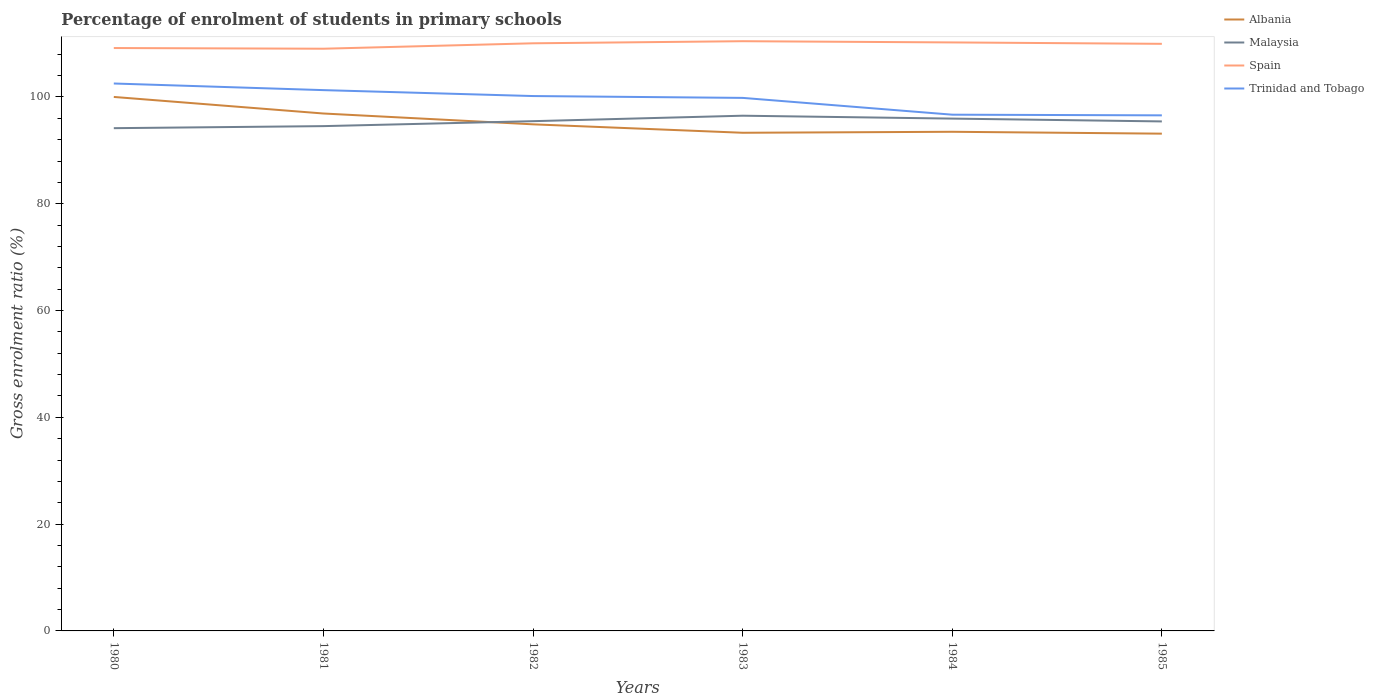How many different coloured lines are there?
Your answer should be very brief. 4. Does the line corresponding to Albania intersect with the line corresponding to Spain?
Offer a terse response. No. Across all years, what is the maximum percentage of students enrolled in primary schools in Malaysia?
Your response must be concise. 94.16. What is the total percentage of students enrolled in primary schools in Spain in the graph?
Offer a very short reply. -0.89. What is the difference between the highest and the second highest percentage of students enrolled in primary schools in Trinidad and Tobago?
Provide a short and direct response. 5.96. Is the percentage of students enrolled in primary schools in Albania strictly greater than the percentage of students enrolled in primary schools in Malaysia over the years?
Provide a short and direct response. No. How many lines are there?
Provide a succinct answer. 4. Are the values on the major ticks of Y-axis written in scientific E-notation?
Your answer should be compact. No. Does the graph contain grids?
Offer a very short reply. No. Where does the legend appear in the graph?
Ensure brevity in your answer.  Top right. What is the title of the graph?
Your response must be concise. Percentage of enrolment of students in primary schools. What is the label or title of the X-axis?
Offer a terse response. Years. What is the label or title of the Y-axis?
Keep it short and to the point. Gross enrolment ratio (%). What is the Gross enrolment ratio (%) in Albania in 1980?
Ensure brevity in your answer.  100.01. What is the Gross enrolment ratio (%) of Malaysia in 1980?
Offer a very short reply. 94.16. What is the Gross enrolment ratio (%) in Spain in 1980?
Your answer should be very brief. 109.17. What is the Gross enrolment ratio (%) in Trinidad and Tobago in 1980?
Provide a short and direct response. 102.53. What is the Gross enrolment ratio (%) of Albania in 1981?
Offer a terse response. 96.91. What is the Gross enrolment ratio (%) of Malaysia in 1981?
Offer a terse response. 94.54. What is the Gross enrolment ratio (%) in Spain in 1981?
Your response must be concise. 109.04. What is the Gross enrolment ratio (%) in Trinidad and Tobago in 1981?
Make the answer very short. 101.29. What is the Gross enrolment ratio (%) of Albania in 1982?
Give a very brief answer. 94.88. What is the Gross enrolment ratio (%) of Malaysia in 1982?
Offer a terse response. 95.47. What is the Gross enrolment ratio (%) in Spain in 1982?
Provide a succinct answer. 110.06. What is the Gross enrolment ratio (%) of Trinidad and Tobago in 1982?
Provide a succinct answer. 100.18. What is the Gross enrolment ratio (%) of Albania in 1983?
Give a very brief answer. 93.3. What is the Gross enrolment ratio (%) of Malaysia in 1983?
Give a very brief answer. 96.5. What is the Gross enrolment ratio (%) in Spain in 1983?
Make the answer very short. 110.45. What is the Gross enrolment ratio (%) of Trinidad and Tobago in 1983?
Your answer should be very brief. 99.83. What is the Gross enrolment ratio (%) of Albania in 1984?
Your response must be concise. 93.49. What is the Gross enrolment ratio (%) of Malaysia in 1984?
Make the answer very short. 95.95. What is the Gross enrolment ratio (%) in Spain in 1984?
Your answer should be compact. 110.22. What is the Gross enrolment ratio (%) of Trinidad and Tobago in 1984?
Provide a short and direct response. 96.69. What is the Gross enrolment ratio (%) of Albania in 1985?
Provide a short and direct response. 93.13. What is the Gross enrolment ratio (%) in Malaysia in 1985?
Provide a short and direct response. 95.43. What is the Gross enrolment ratio (%) in Spain in 1985?
Ensure brevity in your answer.  109.96. What is the Gross enrolment ratio (%) of Trinidad and Tobago in 1985?
Keep it short and to the point. 96.56. Across all years, what is the maximum Gross enrolment ratio (%) of Albania?
Your answer should be very brief. 100.01. Across all years, what is the maximum Gross enrolment ratio (%) of Malaysia?
Give a very brief answer. 96.5. Across all years, what is the maximum Gross enrolment ratio (%) in Spain?
Offer a very short reply. 110.45. Across all years, what is the maximum Gross enrolment ratio (%) of Trinidad and Tobago?
Your response must be concise. 102.53. Across all years, what is the minimum Gross enrolment ratio (%) in Albania?
Provide a succinct answer. 93.13. Across all years, what is the minimum Gross enrolment ratio (%) in Malaysia?
Make the answer very short. 94.16. Across all years, what is the minimum Gross enrolment ratio (%) in Spain?
Your response must be concise. 109.04. Across all years, what is the minimum Gross enrolment ratio (%) of Trinidad and Tobago?
Ensure brevity in your answer.  96.56. What is the total Gross enrolment ratio (%) in Albania in the graph?
Ensure brevity in your answer.  571.72. What is the total Gross enrolment ratio (%) of Malaysia in the graph?
Keep it short and to the point. 572.05. What is the total Gross enrolment ratio (%) of Spain in the graph?
Keep it short and to the point. 658.9. What is the total Gross enrolment ratio (%) in Trinidad and Tobago in the graph?
Provide a succinct answer. 597.08. What is the difference between the Gross enrolment ratio (%) in Albania in 1980 and that in 1981?
Ensure brevity in your answer.  3.1. What is the difference between the Gross enrolment ratio (%) in Malaysia in 1980 and that in 1981?
Give a very brief answer. -0.38. What is the difference between the Gross enrolment ratio (%) of Spain in 1980 and that in 1981?
Make the answer very short. 0.13. What is the difference between the Gross enrolment ratio (%) of Trinidad and Tobago in 1980 and that in 1981?
Provide a short and direct response. 1.24. What is the difference between the Gross enrolment ratio (%) in Albania in 1980 and that in 1982?
Provide a short and direct response. 5.13. What is the difference between the Gross enrolment ratio (%) of Malaysia in 1980 and that in 1982?
Make the answer very short. -1.31. What is the difference between the Gross enrolment ratio (%) in Spain in 1980 and that in 1982?
Keep it short and to the point. -0.89. What is the difference between the Gross enrolment ratio (%) of Trinidad and Tobago in 1980 and that in 1982?
Ensure brevity in your answer.  2.35. What is the difference between the Gross enrolment ratio (%) in Albania in 1980 and that in 1983?
Offer a terse response. 6.71. What is the difference between the Gross enrolment ratio (%) in Malaysia in 1980 and that in 1983?
Ensure brevity in your answer.  -2.34. What is the difference between the Gross enrolment ratio (%) in Spain in 1980 and that in 1983?
Ensure brevity in your answer.  -1.28. What is the difference between the Gross enrolment ratio (%) in Trinidad and Tobago in 1980 and that in 1983?
Offer a very short reply. 2.69. What is the difference between the Gross enrolment ratio (%) in Albania in 1980 and that in 1984?
Give a very brief answer. 6.52. What is the difference between the Gross enrolment ratio (%) in Malaysia in 1980 and that in 1984?
Give a very brief answer. -1.79. What is the difference between the Gross enrolment ratio (%) in Spain in 1980 and that in 1984?
Offer a terse response. -1.05. What is the difference between the Gross enrolment ratio (%) of Trinidad and Tobago in 1980 and that in 1984?
Ensure brevity in your answer.  5.84. What is the difference between the Gross enrolment ratio (%) of Albania in 1980 and that in 1985?
Your answer should be very brief. 6.88. What is the difference between the Gross enrolment ratio (%) in Malaysia in 1980 and that in 1985?
Your answer should be compact. -1.27. What is the difference between the Gross enrolment ratio (%) in Spain in 1980 and that in 1985?
Offer a very short reply. -0.79. What is the difference between the Gross enrolment ratio (%) of Trinidad and Tobago in 1980 and that in 1985?
Keep it short and to the point. 5.96. What is the difference between the Gross enrolment ratio (%) in Albania in 1981 and that in 1982?
Offer a very short reply. 2.03. What is the difference between the Gross enrolment ratio (%) of Malaysia in 1981 and that in 1982?
Your response must be concise. -0.93. What is the difference between the Gross enrolment ratio (%) in Spain in 1981 and that in 1982?
Give a very brief answer. -1.02. What is the difference between the Gross enrolment ratio (%) of Trinidad and Tobago in 1981 and that in 1982?
Ensure brevity in your answer.  1.11. What is the difference between the Gross enrolment ratio (%) in Albania in 1981 and that in 1983?
Your response must be concise. 3.61. What is the difference between the Gross enrolment ratio (%) in Malaysia in 1981 and that in 1983?
Ensure brevity in your answer.  -1.95. What is the difference between the Gross enrolment ratio (%) in Spain in 1981 and that in 1983?
Your response must be concise. -1.41. What is the difference between the Gross enrolment ratio (%) of Trinidad and Tobago in 1981 and that in 1983?
Provide a succinct answer. 1.45. What is the difference between the Gross enrolment ratio (%) of Albania in 1981 and that in 1984?
Provide a succinct answer. 3.42. What is the difference between the Gross enrolment ratio (%) in Malaysia in 1981 and that in 1984?
Give a very brief answer. -1.41. What is the difference between the Gross enrolment ratio (%) of Spain in 1981 and that in 1984?
Ensure brevity in your answer.  -1.18. What is the difference between the Gross enrolment ratio (%) in Trinidad and Tobago in 1981 and that in 1984?
Your response must be concise. 4.6. What is the difference between the Gross enrolment ratio (%) in Albania in 1981 and that in 1985?
Ensure brevity in your answer.  3.77. What is the difference between the Gross enrolment ratio (%) in Malaysia in 1981 and that in 1985?
Your answer should be very brief. -0.88. What is the difference between the Gross enrolment ratio (%) in Spain in 1981 and that in 1985?
Keep it short and to the point. -0.92. What is the difference between the Gross enrolment ratio (%) in Trinidad and Tobago in 1981 and that in 1985?
Keep it short and to the point. 4.72. What is the difference between the Gross enrolment ratio (%) of Albania in 1982 and that in 1983?
Offer a terse response. 1.58. What is the difference between the Gross enrolment ratio (%) of Malaysia in 1982 and that in 1983?
Your answer should be compact. -1.02. What is the difference between the Gross enrolment ratio (%) in Spain in 1982 and that in 1983?
Your answer should be compact. -0.39. What is the difference between the Gross enrolment ratio (%) of Trinidad and Tobago in 1982 and that in 1983?
Provide a short and direct response. 0.34. What is the difference between the Gross enrolment ratio (%) in Albania in 1982 and that in 1984?
Provide a short and direct response. 1.39. What is the difference between the Gross enrolment ratio (%) of Malaysia in 1982 and that in 1984?
Offer a terse response. -0.48. What is the difference between the Gross enrolment ratio (%) of Spain in 1982 and that in 1984?
Your answer should be very brief. -0.17. What is the difference between the Gross enrolment ratio (%) in Trinidad and Tobago in 1982 and that in 1984?
Offer a very short reply. 3.49. What is the difference between the Gross enrolment ratio (%) of Albania in 1982 and that in 1985?
Ensure brevity in your answer.  1.75. What is the difference between the Gross enrolment ratio (%) of Malaysia in 1982 and that in 1985?
Your answer should be compact. 0.05. What is the difference between the Gross enrolment ratio (%) in Spain in 1982 and that in 1985?
Your answer should be compact. 0.1. What is the difference between the Gross enrolment ratio (%) in Trinidad and Tobago in 1982 and that in 1985?
Provide a short and direct response. 3.61. What is the difference between the Gross enrolment ratio (%) in Albania in 1983 and that in 1984?
Offer a terse response. -0.18. What is the difference between the Gross enrolment ratio (%) of Malaysia in 1983 and that in 1984?
Your answer should be compact. 0.54. What is the difference between the Gross enrolment ratio (%) of Spain in 1983 and that in 1984?
Provide a short and direct response. 0.23. What is the difference between the Gross enrolment ratio (%) of Trinidad and Tobago in 1983 and that in 1984?
Keep it short and to the point. 3.15. What is the difference between the Gross enrolment ratio (%) in Albania in 1983 and that in 1985?
Your answer should be very brief. 0.17. What is the difference between the Gross enrolment ratio (%) in Malaysia in 1983 and that in 1985?
Your response must be concise. 1.07. What is the difference between the Gross enrolment ratio (%) in Spain in 1983 and that in 1985?
Offer a very short reply. 0.49. What is the difference between the Gross enrolment ratio (%) of Trinidad and Tobago in 1983 and that in 1985?
Offer a very short reply. 3.27. What is the difference between the Gross enrolment ratio (%) in Albania in 1984 and that in 1985?
Offer a terse response. 0.35. What is the difference between the Gross enrolment ratio (%) of Malaysia in 1984 and that in 1985?
Give a very brief answer. 0.53. What is the difference between the Gross enrolment ratio (%) in Spain in 1984 and that in 1985?
Give a very brief answer. 0.26. What is the difference between the Gross enrolment ratio (%) of Trinidad and Tobago in 1984 and that in 1985?
Your response must be concise. 0.12. What is the difference between the Gross enrolment ratio (%) in Albania in 1980 and the Gross enrolment ratio (%) in Malaysia in 1981?
Keep it short and to the point. 5.47. What is the difference between the Gross enrolment ratio (%) in Albania in 1980 and the Gross enrolment ratio (%) in Spain in 1981?
Give a very brief answer. -9.03. What is the difference between the Gross enrolment ratio (%) of Albania in 1980 and the Gross enrolment ratio (%) of Trinidad and Tobago in 1981?
Your answer should be very brief. -1.28. What is the difference between the Gross enrolment ratio (%) in Malaysia in 1980 and the Gross enrolment ratio (%) in Spain in 1981?
Make the answer very short. -14.88. What is the difference between the Gross enrolment ratio (%) in Malaysia in 1980 and the Gross enrolment ratio (%) in Trinidad and Tobago in 1981?
Give a very brief answer. -7.13. What is the difference between the Gross enrolment ratio (%) of Spain in 1980 and the Gross enrolment ratio (%) of Trinidad and Tobago in 1981?
Give a very brief answer. 7.88. What is the difference between the Gross enrolment ratio (%) of Albania in 1980 and the Gross enrolment ratio (%) of Malaysia in 1982?
Your response must be concise. 4.54. What is the difference between the Gross enrolment ratio (%) in Albania in 1980 and the Gross enrolment ratio (%) in Spain in 1982?
Keep it short and to the point. -10.05. What is the difference between the Gross enrolment ratio (%) in Albania in 1980 and the Gross enrolment ratio (%) in Trinidad and Tobago in 1982?
Ensure brevity in your answer.  -0.17. What is the difference between the Gross enrolment ratio (%) in Malaysia in 1980 and the Gross enrolment ratio (%) in Spain in 1982?
Your answer should be very brief. -15.9. What is the difference between the Gross enrolment ratio (%) of Malaysia in 1980 and the Gross enrolment ratio (%) of Trinidad and Tobago in 1982?
Offer a terse response. -6.02. What is the difference between the Gross enrolment ratio (%) in Spain in 1980 and the Gross enrolment ratio (%) in Trinidad and Tobago in 1982?
Your answer should be compact. 8.99. What is the difference between the Gross enrolment ratio (%) in Albania in 1980 and the Gross enrolment ratio (%) in Malaysia in 1983?
Offer a terse response. 3.51. What is the difference between the Gross enrolment ratio (%) in Albania in 1980 and the Gross enrolment ratio (%) in Spain in 1983?
Give a very brief answer. -10.44. What is the difference between the Gross enrolment ratio (%) in Albania in 1980 and the Gross enrolment ratio (%) in Trinidad and Tobago in 1983?
Your answer should be compact. 0.18. What is the difference between the Gross enrolment ratio (%) in Malaysia in 1980 and the Gross enrolment ratio (%) in Spain in 1983?
Provide a short and direct response. -16.29. What is the difference between the Gross enrolment ratio (%) in Malaysia in 1980 and the Gross enrolment ratio (%) in Trinidad and Tobago in 1983?
Provide a succinct answer. -5.67. What is the difference between the Gross enrolment ratio (%) in Spain in 1980 and the Gross enrolment ratio (%) in Trinidad and Tobago in 1983?
Make the answer very short. 9.34. What is the difference between the Gross enrolment ratio (%) of Albania in 1980 and the Gross enrolment ratio (%) of Malaysia in 1984?
Provide a short and direct response. 4.06. What is the difference between the Gross enrolment ratio (%) of Albania in 1980 and the Gross enrolment ratio (%) of Spain in 1984?
Offer a terse response. -10.21. What is the difference between the Gross enrolment ratio (%) of Albania in 1980 and the Gross enrolment ratio (%) of Trinidad and Tobago in 1984?
Make the answer very short. 3.32. What is the difference between the Gross enrolment ratio (%) in Malaysia in 1980 and the Gross enrolment ratio (%) in Spain in 1984?
Your response must be concise. -16.06. What is the difference between the Gross enrolment ratio (%) of Malaysia in 1980 and the Gross enrolment ratio (%) of Trinidad and Tobago in 1984?
Keep it short and to the point. -2.53. What is the difference between the Gross enrolment ratio (%) in Spain in 1980 and the Gross enrolment ratio (%) in Trinidad and Tobago in 1984?
Your response must be concise. 12.48. What is the difference between the Gross enrolment ratio (%) in Albania in 1980 and the Gross enrolment ratio (%) in Malaysia in 1985?
Provide a short and direct response. 4.59. What is the difference between the Gross enrolment ratio (%) of Albania in 1980 and the Gross enrolment ratio (%) of Spain in 1985?
Provide a succinct answer. -9.95. What is the difference between the Gross enrolment ratio (%) of Albania in 1980 and the Gross enrolment ratio (%) of Trinidad and Tobago in 1985?
Offer a terse response. 3.45. What is the difference between the Gross enrolment ratio (%) of Malaysia in 1980 and the Gross enrolment ratio (%) of Spain in 1985?
Your answer should be compact. -15.8. What is the difference between the Gross enrolment ratio (%) in Malaysia in 1980 and the Gross enrolment ratio (%) in Trinidad and Tobago in 1985?
Make the answer very short. -2.4. What is the difference between the Gross enrolment ratio (%) of Spain in 1980 and the Gross enrolment ratio (%) of Trinidad and Tobago in 1985?
Your response must be concise. 12.61. What is the difference between the Gross enrolment ratio (%) in Albania in 1981 and the Gross enrolment ratio (%) in Malaysia in 1982?
Provide a succinct answer. 1.44. What is the difference between the Gross enrolment ratio (%) in Albania in 1981 and the Gross enrolment ratio (%) in Spain in 1982?
Your response must be concise. -13.15. What is the difference between the Gross enrolment ratio (%) in Albania in 1981 and the Gross enrolment ratio (%) in Trinidad and Tobago in 1982?
Ensure brevity in your answer.  -3.27. What is the difference between the Gross enrolment ratio (%) in Malaysia in 1981 and the Gross enrolment ratio (%) in Spain in 1982?
Your answer should be compact. -15.51. What is the difference between the Gross enrolment ratio (%) of Malaysia in 1981 and the Gross enrolment ratio (%) of Trinidad and Tobago in 1982?
Provide a short and direct response. -5.63. What is the difference between the Gross enrolment ratio (%) of Spain in 1981 and the Gross enrolment ratio (%) of Trinidad and Tobago in 1982?
Your answer should be compact. 8.86. What is the difference between the Gross enrolment ratio (%) of Albania in 1981 and the Gross enrolment ratio (%) of Malaysia in 1983?
Your response must be concise. 0.41. What is the difference between the Gross enrolment ratio (%) of Albania in 1981 and the Gross enrolment ratio (%) of Spain in 1983?
Your answer should be compact. -13.54. What is the difference between the Gross enrolment ratio (%) of Albania in 1981 and the Gross enrolment ratio (%) of Trinidad and Tobago in 1983?
Provide a short and direct response. -2.93. What is the difference between the Gross enrolment ratio (%) of Malaysia in 1981 and the Gross enrolment ratio (%) of Spain in 1983?
Offer a terse response. -15.91. What is the difference between the Gross enrolment ratio (%) of Malaysia in 1981 and the Gross enrolment ratio (%) of Trinidad and Tobago in 1983?
Make the answer very short. -5.29. What is the difference between the Gross enrolment ratio (%) of Spain in 1981 and the Gross enrolment ratio (%) of Trinidad and Tobago in 1983?
Your answer should be compact. 9.21. What is the difference between the Gross enrolment ratio (%) of Albania in 1981 and the Gross enrolment ratio (%) of Malaysia in 1984?
Ensure brevity in your answer.  0.95. What is the difference between the Gross enrolment ratio (%) in Albania in 1981 and the Gross enrolment ratio (%) in Spain in 1984?
Offer a very short reply. -13.31. What is the difference between the Gross enrolment ratio (%) in Albania in 1981 and the Gross enrolment ratio (%) in Trinidad and Tobago in 1984?
Your answer should be compact. 0.22. What is the difference between the Gross enrolment ratio (%) of Malaysia in 1981 and the Gross enrolment ratio (%) of Spain in 1984?
Keep it short and to the point. -15.68. What is the difference between the Gross enrolment ratio (%) in Malaysia in 1981 and the Gross enrolment ratio (%) in Trinidad and Tobago in 1984?
Make the answer very short. -2.14. What is the difference between the Gross enrolment ratio (%) in Spain in 1981 and the Gross enrolment ratio (%) in Trinidad and Tobago in 1984?
Your answer should be very brief. 12.35. What is the difference between the Gross enrolment ratio (%) in Albania in 1981 and the Gross enrolment ratio (%) in Malaysia in 1985?
Ensure brevity in your answer.  1.48. What is the difference between the Gross enrolment ratio (%) in Albania in 1981 and the Gross enrolment ratio (%) in Spain in 1985?
Your answer should be compact. -13.05. What is the difference between the Gross enrolment ratio (%) of Albania in 1981 and the Gross enrolment ratio (%) of Trinidad and Tobago in 1985?
Your response must be concise. 0.34. What is the difference between the Gross enrolment ratio (%) in Malaysia in 1981 and the Gross enrolment ratio (%) in Spain in 1985?
Provide a succinct answer. -15.41. What is the difference between the Gross enrolment ratio (%) of Malaysia in 1981 and the Gross enrolment ratio (%) of Trinidad and Tobago in 1985?
Offer a terse response. -2.02. What is the difference between the Gross enrolment ratio (%) in Spain in 1981 and the Gross enrolment ratio (%) in Trinidad and Tobago in 1985?
Offer a very short reply. 12.48. What is the difference between the Gross enrolment ratio (%) of Albania in 1982 and the Gross enrolment ratio (%) of Malaysia in 1983?
Give a very brief answer. -1.61. What is the difference between the Gross enrolment ratio (%) in Albania in 1982 and the Gross enrolment ratio (%) in Spain in 1983?
Offer a very short reply. -15.57. What is the difference between the Gross enrolment ratio (%) of Albania in 1982 and the Gross enrolment ratio (%) of Trinidad and Tobago in 1983?
Your answer should be compact. -4.95. What is the difference between the Gross enrolment ratio (%) in Malaysia in 1982 and the Gross enrolment ratio (%) in Spain in 1983?
Your answer should be compact. -14.98. What is the difference between the Gross enrolment ratio (%) of Malaysia in 1982 and the Gross enrolment ratio (%) of Trinidad and Tobago in 1983?
Give a very brief answer. -4.36. What is the difference between the Gross enrolment ratio (%) of Spain in 1982 and the Gross enrolment ratio (%) of Trinidad and Tobago in 1983?
Your answer should be compact. 10.22. What is the difference between the Gross enrolment ratio (%) of Albania in 1982 and the Gross enrolment ratio (%) of Malaysia in 1984?
Keep it short and to the point. -1.07. What is the difference between the Gross enrolment ratio (%) of Albania in 1982 and the Gross enrolment ratio (%) of Spain in 1984?
Your response must be concise. -15.34. What is the difference between the Gross enrolment ratio (%) in Albania in 1982 and the Gross enrolment ratio (%) in Trinidad and Tobago in 1984?
Provide a succinct answer. -1.81. What is the difference between the Gross enrolment ratio (%) of Malaysia in 1982 and the Gross enrolment ratio (%) of Spain in 1984?
Offer a very short reply. -14.75. What is the difference between the Gross enrolment ratio (%) in Malaysia in 1982 and the Gross enrolment ratio (%) in Trinidad and Tobago in 1984?
Your answer should be very brief. -1.22. What is the difference between the Gross enrolment ratio (%) in Spain in 1982 and the Gross enrolment ratio (%) in Trinidad and Tobago in 1984?
Your answer should be very brief. 13.37. What is the difference between the Gross enrolment ratio (%) in Albania in 1982 and the Gross enrolment ratio (%) in Malaysia in 1985?
Provide a succinct answer. -0.54. What is the difference between the Gross enrolment ratio (%) in Albania in 1982 and the Gross enrolment ratio (%) in Spain in 1985?
Make the answer very short. -15.08. What is the difference between the Gross enrolment ratio (%) in Albania in 1982 and the Gross enrolment ratio (%) in Trinidad and Tobago in 1985?
Keep it short and to the point. -1.68. What is the difference between the Gross enrolment ratio (%) in Malaysia in 1982 and the Gross enrolment ratio (%) in Spain in 1985?
Offer a very short reply. -14.49. What is the difference between the Gross enrolment ratio (%) of Malaysia in 1982 and the Gross enrolment ratio (%) of Trinidad and Tobago in 1985?
Ensure brevity in your answer.  -1.09. What is the difference between the Gross enrolment ratio (%) in Spain in 1982 and the Gross enrolment ratio (%) in Trinidad and Tobago in 1985?
Provide a short and direct response. 13.49. What is the difference between the Gross enrolment ratio (%) of Albania in 1983 and the Gross enrolment ratio (%) of Malaysia in 1984?
Give a very brief answer. -2.65. What is the difference between the Gross enrolment ratio (%) in Albania in 1983 and the Gross enrolment ratio (%) in Spain in 1984?
Your response must be concise. -16.92. What is the difference between the Gross enrolment ratio (%) of Albania in 1983 and the Gross enrolment ratio (%) of Trinidad and Tobago in 1984?
Your answer should be compact. -3.39. What is the difference between the Gross enrolment ratio (%) of Malaysia in 1983 and the Gross enrolment ratio (%) of Spain in 1984?
Offer a terse response. -13.73. What is the difference between the Gross enrolment ratio (%) of Malaysia in 1983 and the Gross enrolment ratio (%) of Trinidad and Tobago in 1984?
Keep it short and to the point. -0.19. What is the difference between the Gross enrolment ratio (%) in Spain in 1983 and the Gross enrolment ratio (%) in Trinidad and Tobago in 1984?
Provide a succinct answer. 13.76. What is the difference between the Gross enrolment ratio (%) of Albania in 1983 and the Gross enrolment ratio (%) of Malaysia in 1985?
Offer a terse response. -2.12. What is the difference between the Gross enrolment ratio (%) in Albania in 1983 and the Gross enrolment ratio (%) in Spain in 1985?
Offer a very short reply. -16.66. What is the difference between the Gross enrolment ratio (%) of Albania in 1983 and the Gross enrolment ratio (%) of Trinidad and Tobago in 1985?
Offer a terse response. -3.26. What is the difference between the Gross enrolment ratio (%) in Malaysia in 1983 and the Gross enrolment ratio (%) in Spain in 1985?
Your response must be concise. -13.46. What is the difference between the Gross enrolment ratio (%) in Malaysia in 1983 and the Gross enrolment ratio (%) in Trinidad and Tobago in 1985?
Ensure brevity in your answer.  -0.07. What is the difference between the Gross enrolment ratio (%) in Spain in 1983 and the Gross enrolment ratio (%) in Trinidad and Tobago in 1985?
Your answer should be very brief. 13.89. What is the difference between the Gross enrolment ratio (%) in Albania in 1984 and the Gross enrolment ratio (%) in Malaysia in 1985?
Your answer should be compact. -1.94. What is the difference between the Gross enrolment ratio (%) in Albania in 1984 and the Gross enrolment ratio (%) in Spain in 1985?
Offer a terse response. -16.47. What is the difference between the Gross enrolment ratio (%) in Albania in 1984 and the Gross enrolment ratio (%) in Trinidad and Tobago in 1985?
Ensure brevity in your answer.  -3.08. What is the difference between the Gross enrolment ratio (%) of Malaysia in 1984 and the Gross enrolment ratio (%) of Spain in 1985?
Your answer should be very brief. -14. What is the difference between the Gross enrolment ratio (%) of Malaysia in 1984 and the Gross enrolment ratio (%) of Trinidad and Tobago in 1985?
Provide a short and direct response. -0.61. What is the difference between the Gross enrolment ratio (%) in Spain in 1984 and the Gross enrolment ratio (%) in Trinidad and Tobago in 1985?
Provide a succinct answer. 13.66. What is the average Gross enrolment ratio (%) in Albania per year?
Keep it short and to the point. 95.29. What is the average Gross enrolment ratio (%) in Malaysia per year?
Offer a very short reply. 95.34. What is the average Gross enrolment ratio (%) of Spain per year?
Your answer should be compact. 109.82. What is the average Gross enrolment ratio (%) of Trinidad and Tobago per year?
Provide a short and direct response. 99.51. In the year 1980, what is the difference between the Gross enrolment ratio (%) of Albania and Gross enrolment ratio (%) of Malaysia?
Your answer should be very brief. 5.85. In the year 1980, what is the difference between the Gross enrolment ratio (%) in Albania and Gross enrolment ratio (%) in Spain?
Keep it short and to the point. -9.16. In the year 1980, what is the difference between the Gross enrolment ratio (%) in Albania and Gross enrolment ratio (%) in Trinidad and Tobago?
Ensure brevity in your answer.  -2.52. In the year 1980, what is the difference between the Gross enrolment ratio (%) of Malaysia and Gross enrolment ratio (%) of Spain?
Your response must be concise. -15.01. In the year 1980, what is the difference between the Gross enrolment ratio (%) of Malaysia and Gross enrolment ratio (%) of Trinidad and Tobago?
Ensure brevity in your answer.  -8.37. In the year 1980, what is the difference between the Gross enrolment ratio (%) of Spain and Gross enrolment ratio (%) of Trinidad and Tobago?
Ensure brevity in your answer.  6.64. In the year 1981, what is the difference between the Gross enrolment ratio (%) in Albania and Gross enrolment ratio (%) in Malaysia?
Keep it short and to the point. 2.36. In the year 1981, what is the difference between the Gross enrolment ratio (%) of Albania and Gross enrolment ratio (%) of Spain?
Your response must be concise. -12.13. In the year 1981, what is the difference between the Gross enrolment ratio (%) in Albania and Gross enrolment ratio (%) in Trinidad and Tobago?
Ensure brevity in your answer.  -4.38. In the year 1981, what is the difference between the Gross enrolment ratio (%) in Malaysia and Gross enrolment ratio (%) in Spain?
Ensure brevity in your answer.  -14.5. In the year 1981, what is the difference between the Gross enrolment ratio (%) in Malaysia and Gross enrolment ratio (%) in Trinidad and Tobago?
Offer a terse response. -6.74. In the year 1981, what is the difference between the Gross enrolment ratio (%) in Spain and Gross enrolment ratio (%) in Trinidad and Tobago?
Offer a terse response. 7.75. In the year 1982, what is the difference between the Gross enrolment ratio (%) in Albania and Gross enrolment ratio (%) in Malaysia?
Provide a short and direct response. -0.59. In the year 1982, what is the difference between the Gross enrolment ratio (%) in Albania and Gross enrolment ratio (%) in Spain?
Your answer should be very brief. -15.18. In the year 1982, what is the difference between the Gross enrolment ratio (%) in Albania and Gross enrolment ratio (%) in Trinidad and Tobago?
Keep it short and to the point. -5.3. In the year 1982, what is the difference between the Gross enrolment ratio (%) of Malaysia and Gross enrolment ratio (%) of Spain?
Give a very brief answer. -14.59. In the year 1982, what is the difference between the Gross enrolment ratio (%) of Malaysia and Gross enrolment ratio (%) of Trinidad and Tobago?
Your response must be concise. -4.71. In the year 1982, what is the difference between the Gross enrolment ratio (%) in Spain and Gross enrolment ratio (%) in Trinidad and Tobago?
Offer a terse response. 9.88. In the year 1983, what is the difference between the Gross enrolment ratio (%) in Albania and Gross enrolment ratio (%) in Malaysia?
Provide a short and direct response. -3.19. In the year 1983, what is the difference between the Gross enrolment ratio (%) of Albania and Gross enrolment ratio (%) of Spain?
Ensure brevity in your answer.  -17.15. In the year 1983, what is the difference between the Gross enrolment ratio (%) in Albania and Gross enrolment ratio (%) in Trinidad and Tobago?
Give a very brief answer. -6.53. In the year 1983, what is the difference between the Gross enrolment ratio (%) of Malaysia and Gross enrolment ratio (%) of Spain?
Ensure brevity in your answer.  -13.95. In the year 1983, what is the difference between the Gross enrolment ratio (%) of Malaysia and Gross enrolment ratio (%) of Trinidad and Tobago?
Offer a very short reply. -3.34. In the year 1983, what is the difference between the Gross enrolment ratio (%) in Spain and Gross enrolment ratio (%) in Trinidad and Tobago?
Offer a very short reply. 10.62. In the year 1984, what is the difference between the Gross enrolment ratio (%) of Albania and Gross enrolment ratio (%) of Malaysia?
Offer a terse response. -2.47. In the year 1984, what is the difference between the Gross enrolment ratio (%) in Albania and Gross enrolment ratio (%) in Spain?
Ensure brevity in your answer.  -16.74. In the year 1984, what is the difference between the Gross enrolment ratio (%) in Albania and Gross enrolment ratio (%) in Trinidad and Tobago?
Offer a very short reply. -3.2. In the year 1984, what is the difference between the Gross enrolment ratio (%) in Malaysia and Gross enrolment ratio (%) in Spain?
Give a very brief answer. -14.27. In the year 1984, what is the difference between the Gross enrolment ratio (%) in Malaysia and Gross enrolment ratio (%) in Trinidad and Tobago?
Your response must be concise. -0.73. In the year 1984, what is the difference between the Gross enrolment ratio (%) of Spain and Gross enrolment ratio (%) of Trinidad and Tobago?
Your answer should be compact. 13.53. In the year 1985, what is the difference between the Gross enrolment ratio (%) in Albania and Gross enrolment ratio (%) in Malaysia?
Keep it short and to the point. -2.29. In the year 1985, what is the difference between the Gross enrolment ratio (%) in Albania and Gross enrolment ratio (%) in Spain?
Provide a short and direct response. -16.82. In the year 1985, what is the difference between the Gross enrolment ratio (%) in Albania and Gross enrolment ratio (%) in Trinidad and Tobago?
Your response must be concise. -3.43. In the year 1985, what is the difference between the Gross enrolment ratio (%) in Malaysia and Gross enrolment ratio (%) in Spain?
Offer a terse response. -14.53. In the year 1985, what is the difference between the Gross enrolment ratio (%) of Malaysia and Gross enrolment ratio (%) of Trinidad and Tobago?
Provide a short and direct response. -1.14. In the year 1985, what is the difference between the Gross enrolment ratio (%) of Spain and Gross enrolment ratio (%) of Trinidad and Tobago?
Provide a short and direct response. 13.39. What is the ratio of the Gross enrolment ratio (%) of Albania in 1980 to that in 1981?
Offer a very short reply. 1.03. What is the ratio of the Gross enrolment ratio (%) in Trinidad and Tobago in 1980 to that in 1981?
Your answer should be very brief. 1.01. What is the ratio of the Gross enrolment ratio (%) in Albania in 1980 to that in 1982?
Your answer should be compact. 1.05. What is the ratio of the Gross enrolment ratio (%) in Malaysia in 1980 to that in 1982?
Keep it short and to the point. 0.99. What is the ratio of the Gross enrolment ratio (%) of Spain in 1980 to that in 1982?
Provide a succinct answer. 0.99. What is the ratio of the Gross enrolment ratio (%) in Trinidad and Tobago in 1980 to that in 1982?
Give a very brief answer. 1.02. What is the ratio of the Gross enrolment ratio (%) of Albania in 1980 to that in 1983?
Ensure brevity in your answer.  1.07. What is the ratio of the Gross enrolment ratio (%) in Malaysia in 1980 to that in 1983?
Offer a very short reply. 0.98. What is the ratio of the Gross enrolment ratio (%) of Spain in 1980 to that in 1983?
Your answer should be very brief. 0.99. What is the ratio of the Gross enrolment ratio (%) of Trinidad and Tobago in 1980 to that in 1983?
Your answer should be compact. 1.03. What is the ratio of the Gross enrolment ratio (%) in Albania in 1980 to that in 1984?
Give a very brief answer. 1.07. What is the ratio of the Gross enrolment ratio (%) in Malaysia in 1980 to that in 1984?
Make the answer very short. 0.98. What is the ratio of the Gross enrolment ratio (%) of Spain in 1980 to that in 1984?
Keep it short and to the point. 0.99. What is the ratio of the Gross enrolment ratio (%) in Trinidad and Tobago in 1980 to that in 1984?
Give a very brief answer. 1.06. What is the ratio of the Gross enrolment ratio (%) of Albania in 1980 to that in 1985?
Provide a succinct answer. 1.07. What is the ratio of the Gross enrolment ratio (%) of Malaysia in 1980 to that in 1985?
Provide a short and direct response. 0.99. What is the ratio of the Gross enrolment ratio (%) of Spain in 1980 to that in 1985?
Make the answer very short. 0.99. What is the ratio of the Gross enrolment ratio (%) in Trinidad and Tobago in 1980 to that in 1985?
Offer a very short reply. 1.06. What is the ratio of the Gross enrolment ratio (%) in Albania in 1981 to that in 1982?
Your response must be concise. 1.02. What is the ratio of the Gross enrolment ratio (%) in Malaysia in 1981 to that in 1982?
Give a very brief answer. 0.99. What is the ratio of the Gross enrolment ratio (%) of Spain in 1981 to that in 1982?
Offer a very short reply. 0.99. What is the ratio of the Gross enrolment ratio (%) in Trinidad and Tobago in 1981 to that in 1982?
Offer a terse response. 1.01. What is the ratio of the Gross enrolment ratio (%) in Albania in 1981 to that in 1983?
Give a very brief answer. 1.04. What is the ratio of the Gross enrolment ratio (%) of Malaysia in 1981 to that in 1983?
Your answer should be very brief. 0.98. What is the ratio of the Gross enrolment ratio (%) in Spain in 1981 to that in 1983?
Your answer should be compact. 0.99. What is the ratio of the Gross enrolment ratio (%) in Trinidad and Tobago in 1981 to that in 1983?
Provide a short and direct response. 1.01. What is the ratio of the Gross enrolment ratio (%) of Albania in 1981 to that in 1984?
Keep it short and to the point. 1.04. What is the ratio of the Gross enrolment ratio (%) in Spain in 1981 to that in 1984?
Offer a very short reply. 0.99. What is the ratio of the Gross enrolment ratio (%) of Trinidad and Tobago in 1981 to that in 1984?
Your answer should be very brief. 1.05. What is the ratio of the Gross enrolment ratio (%) of Albania in 1981 to that in 1985?
Keep it short and to the point. 1.04. What is the ratio of the Gross enrolment ratio (%) in Malaysia in 1981 to that in 1985?
Keep it short and to the point. 0.99. What is the ratio of the Gross enrolment ratio (%) in Spain in 1981 to that in 1985?
Provide a short and direct response. 0.99. What is the ratio of the Gross enrolment ratio (%) of Trinidad and Tobago in 1981 to that in 1985?
Ensure brevity in your answer.  1.05. What is the ratio of the Gross enrolment ratio (%) in Albania in 1982 to that in 1983?
Your answer should be very brief. 1.02. What is the ratio of the Gross enrolment ratio (%) in Malaysia in 1982 to that in 1983?
Give a very brief answer. 0.99. What is the ratio of the Gross enrolment ratio (%) in Albania in 1982 to that in 1984?
Offer a very short reply. 1.01. What is the ratio of the Gross enrolment ratio (%) of Malaysia in 1982 to that in 1984?
Your response must be concise. 0.99. What is the ratio of the Gross enrolment ratio (%) in Trinidad and Tobago in 1982 to that in 1984?
Your answer should be compact. 1.04. What is the ratio of the Gross enrolment ratio (%) in Albania in 1982 to that in 1985?
Offer a very short reply. 1.02. What is the ratio of the Gross enrolment ratio (%) of Malaysia in 1982 to that in 1985?
Offer a very short reply. 1. What is the ratio of the Gross enrolment ratio (%) of Trinidad and Tobago in 1982 to that in 1985?
Offer a very short reply. 1.04. What is the ratio of the Gross enrolment ratio (%) in Albania in 1983 to that in 1984?
Offer a terse response. 1. What is the ratio of the Gross enrolment ratio (%) in Malaysia in 1983 to that in 1984?
Make the answer very short. 1.01. What is the ratio of the Gross enrolment ratio (%) of Trinidad and Tobago in 1983 to that in 1984?
Ensure brevity in your answer.  1.03. What is the ratio of the Gross enrolment ratio (%) in Albania in 1983 to that in 1985?
Your response must be concise. 1. What is the ratio of the Gross enrolment ratio (%) of Malaysia in 1983 to that in 1985?
Your response must be concise. 1.01. What is the ratio of the Gross enrolment ratio (%) in Spain in 1983 to that in 1985?
Give a very brief answer. 1. What is the ratio of the Gross enrolment ratio (%) in Trinidad and Tobago in 1983 to that in 1985?
Keep it short and to the point. 1.03. What is the ratio of the Gross enrolment ratio (%) of Spain in 1984 to that in 1985?
Keep it short and to the point. 1. What is the ratio of the Gross enrolment ratio (%) of Trinidad and Tobago in 1984 to that in 1985?
Offer a very short reply. 1. What is the difference between the highest and the second highest Gross enrolment ratio (%) of Albania?
Your answer should be compact. 3.1. What is the difference between the highest and the second highest Gross enrolment ratio (%) of Malaysia?
Give a very brief answer. 0.54. What is the difference between the highest and the second highest Gross enrolment ratio (%) of Spain?
Your response must be concise. 0.23. What is the difference between the highest and the second highest Gross enrolment ratio (%) of Trinidad and Tobago?
Offer a terse response. 1.24. What is the difference between the highest and the lowest Gross enrolment ratio (%) in Albania?
Provide a succinct answer. 6.88. What is the difference between the highest and the lowest Gross enrolment ratio (%) in Malaysia?
Your answer should be very brief. 2.34. What is the difference between the highest and the lowest Gross enrolment ratio (%) of Spain?
Give a very brief answer. 1.41. What is the difference between the highest and the lowest Gross enrolment ratio (%) of Trinidad and Tobago?
Offer a terse response. 5.96. 